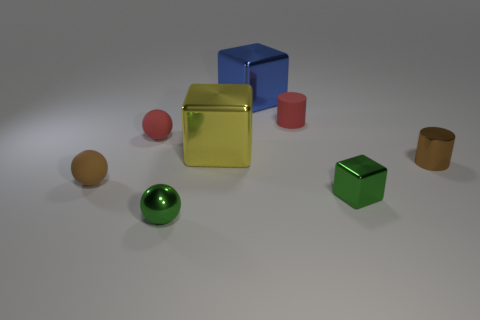Does the metal cube that is in front of the brown sphere have the same color as the tiny metal ball?
Keep it short and to the point. Yes. What material is the small thing that is the same color as the small shiny sphere?
Offer a terse response. Metal. What number of rubber things are the same color as the tiny metallic cylinder?
Ensure brevity in your answer.  1. There is a large metallic object left of the big blue metallic thing; is it the same shape as the small brown metal object?
Your answer should be very brief. No. Are there fewer red rubber things on the right side of the blue shiny object than small red matte things behind the small block?
Keep it short and to the point. Yes. There is a tiny green thing that is in front of the small green cube; what material is it?
Your response must be concise. Metal. There is a object that is the same color as the tiny metallic cylinder; what is its size?
Your answer should be very brief. Small. Are there any red cylinders that have the same size as the shiny sphere?
Offer a terse response. Yes. There is a yellow metallic object; does it have the same shape as the small green shiny thing that is behind the tiny metallic ball?
Provide a succinct answer. Yes. Does the green object to the right of the large blue object have the same size as the green object that is left of the green metallic block?
Give a very brief answer. Yes. 